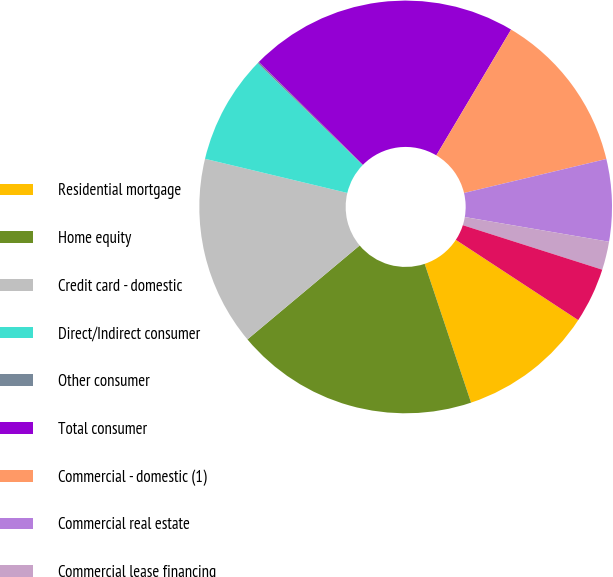Convert chart. <chart><loc_0><loc_0><loc_500><loc_500><pie_chart><fcel>Residential mortgage<fcel>Home equity<fcel>Credit card - domestic<fcel>Direct/Indirect consumer<fcel>Other consumer<fcel>Total consumer<fcel>Commercial - domestic (1)<fcel>Commercial real estate<fcel>Commercial lease financing<fcel>Commercial - foreign<nl><fcel>10.63%<fcel>19.04%<fcel>14.84%<fcel>8.53%<fcel>0.12%<fcel>21.14%<fcel>12.73%<fcel>6.43%<fcel>2.22%<fcel>4.32%<nl></chart> 